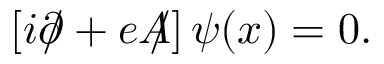<formula> <loc_0><loc_0><loc_500><loc_500>\left [ i \partial \, / + e A \, / \right ] \psi ( x ) = 0 .</formula> 